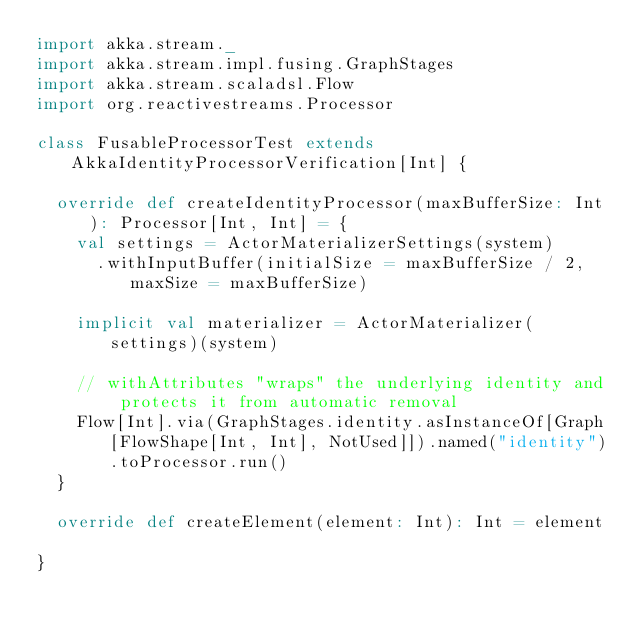<code> <loc_0><loc_0><loc_500><loc_500><_Scala_>import akka.stream._
import akka.stream.impl.fusing.GraphStages
import akka.stream.scaladsl.Flow
import org.reactivestreams.Processor

class FusableProcessorTest extends AkkaIdentityProcessorVerification[Int] {

  override def createIdentityProcessor(maxBufferSize: Int): Processor[Int, Int] = {
    val settings = ActorMaterializerSettings(system)
      .withInputBuffer(initialSize = maxBufferSize / 2, maxSize = maxBufferSize)

    implicit val materializer = ActorMaterializer(settings)(system)

    // withAttributes "wraps" the underlying identity and protects it from automatic removal
    Flow[Int].via(GraphStages.identity.asInstanceOf[Graph[FlowShape[Int, Int], NotUsed]]).named("identity").toProcessor.run()
  }

  override def createElement(element: Int): Int = element

}
</code> 